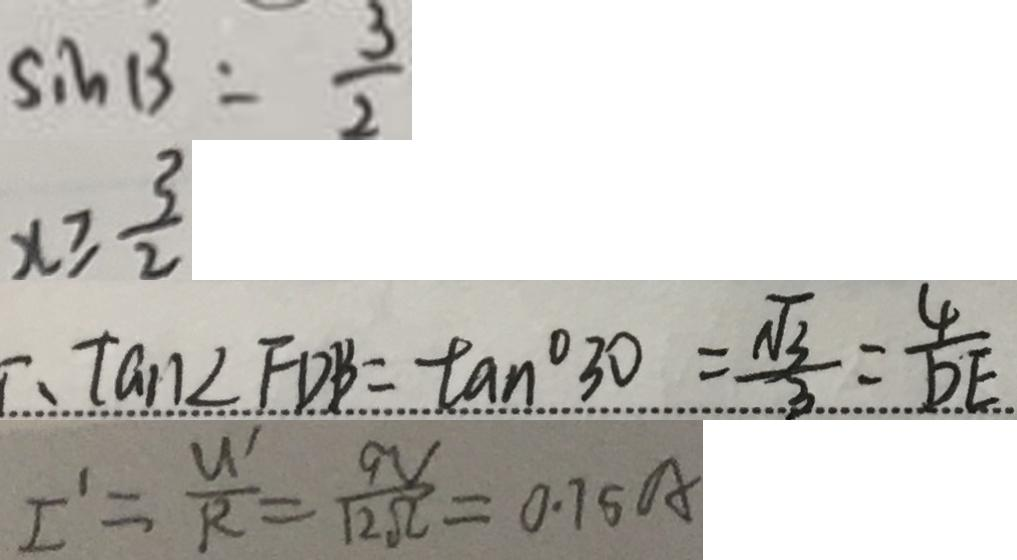<formula> <loc_0><loc_0><loc_500><loc_500>S i n 1 3 = \frac { 3 } { 2 } 
 x \geq \frac { 3 } { 2 } 
 \therefore \tan \angle F D B = \tan ^ { \circ } 3 0 = \frac { \sqrt { 3 } } { 3 } = \frac { 4 } { D E } 
 I ^ { \prime } = \frac { U ^ { \prime } } { R } = \frac { 9 V } { 1 2 \Omega } = 0 . 7 5 A</formula> 